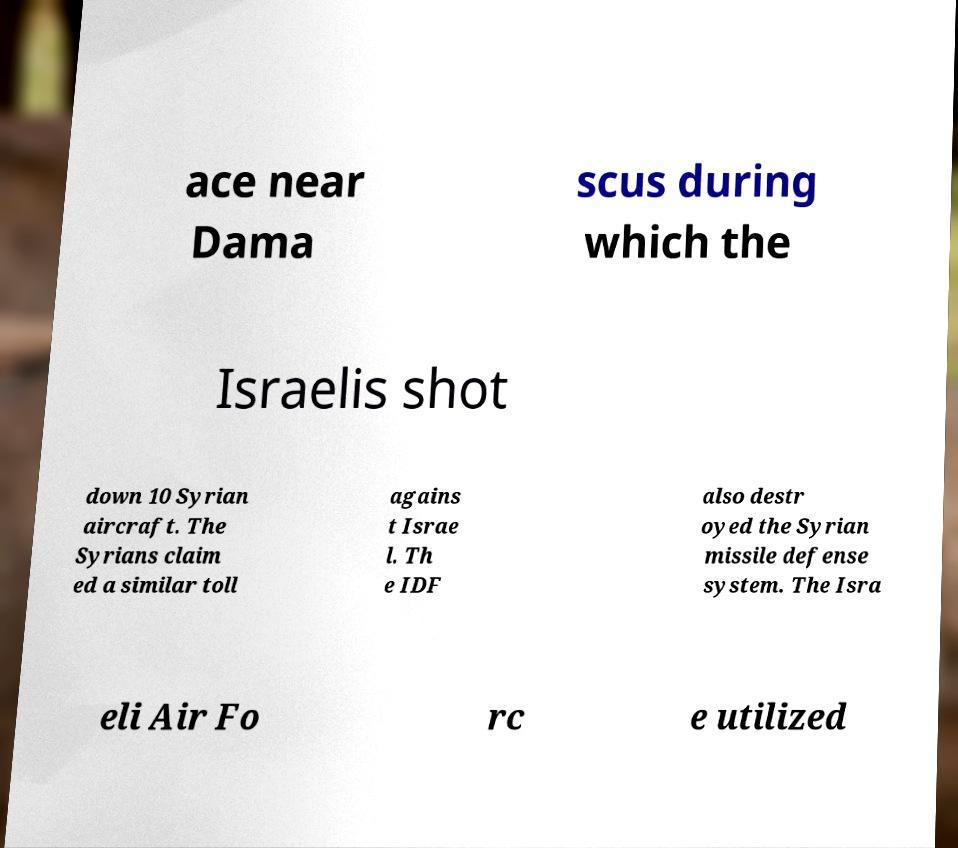Please identify and transcribe the text found in this image. ace near Dama scus during which the Israelis shot down 10 Syrian aircraft. The Syrians claim ed a similar toll agains t Israe l. Th e IDF also destr oyed the Syrian missile defense system. The Isra eli Air Fo rc e utilized 